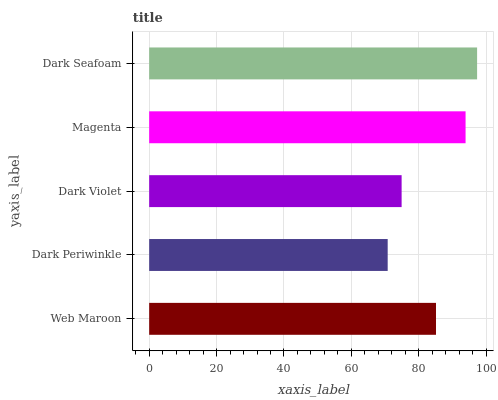Is Dark Periwinkle the minimum?
Answer yes or no. Yes. Is Dark Seafoam the maximum?
Answer yes or no. Yes. Is Dark Violet the minimum?
Answer yes or no. No. Is Dark Violet the maximum?
Answer yes or no. No. Is Dark Violet greater than Dark Periwinkle?
Answer yes or no. Yes. Is Dark Periwinkle less than Dark Violet?
Answer yes or no. Yes. Is Dark Periwinkle greater than Dark Violet?
Answer yes or no. No. Is Dark Violet less than Dark Periwinkle?
Answer yes or no. No. Is Web Maroon the high median?
Answer yes or no. Yes. Is Web Maroon the low median?
Answer yes or no. Yes. Is Dark Seafoam the high median?
Answer yes or no. No. Is Dark Periwinkle the low median?
Answer yes or no. No. 